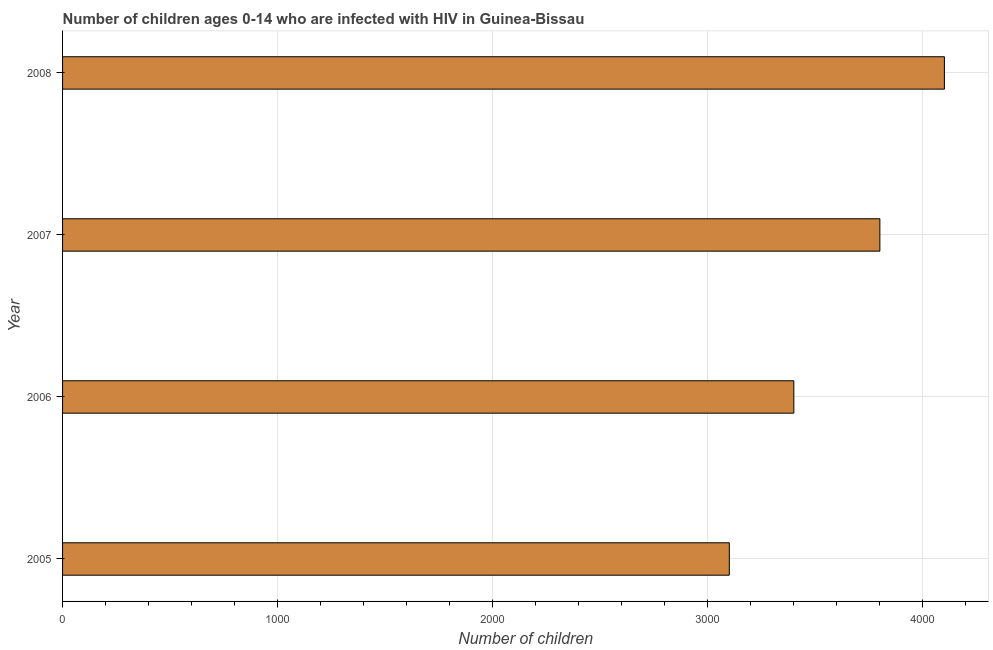Does the graph contain any zero values?
Your answer should be compact. No. Does the graph contain grids?
Give a very brief answer. Yes. What is the title of the graph?
Give a very brief answer. Number of children ages 0-14 who are infected with HIV in Guinea-Bissau. What is the label or title of the X-axis?
Make the answer very short. Number of children. What is the number of children living with hiv in 2008?
Your answer should be compact. 4100. Across all years, what is the maximum number of children living with hiv?
Provide a succinct answer. 4100. Across all years, what is the minimum number of children living with hiv?
Keep it short and to the point. 3100. In which year was the number of children living with hiv maximum?
Your response must be concise. 2008. In which year was the number of children living with hiv minimum?
Your answer should be very brief. 2005. What is the sum of the number of children living with hiv?
Ensure brevity in your answer.  1.44e+04. What is the difference between the number of children living with hiv in 2006 and 2008?
Keep it short and to the point. -700. What is the average number of children living with hiv per year?
Keep it short and to the point. 3600. What is the median number of children living with hiv?
Your answer should be compact. 3600. Do a majority of the years between 2008 and 2007 (inclusive) have number of children living with hiv greater than 200 ?
Offer a terse response. No. What is the ratio of the number of children living with hiv in 2005 to that in 2007?
Provide a short and direct response. 0.82. Is the difference between the number of children living with hiv in 2007 and 2008 greater than the difference between any two years?
Make the answer very short. No. What is the difference between the highest and the second highest number of children living with hiv?
Provide a short and direct response. 300. Is the sum of the number of children living with hiv in 2007 and 2008 greater than the maximum number of children living with hiv across all years?
Your answer should be very brief. Yes. What is the difference between the highest and the lowest number of children living with hiv?
Give a very brief answer. 1000. How many bars are there?
Your answer should be very brief. 4. What is the difference between two consecutive major ticks on the X-axis?
Provide a succinct answer. 1000. Are the values on the major ticks of X-axis written in scientific E-notation?
Your answer should be very brief. No. What is the Number of children in 2005?
Your answer should be very brief. 3100. What is the Number of children in 2006?
Ensure brevity in your answer.  3400. What is the Number of children of 2007?
Provide a short and direct response. 3800. What is the Number of children of 2008?
Ensure brevity in your answer.  4100. What is the difference between the Number of children in 2005 and 2006?
Your response must be concise. -300. What is the difference between the Number of children in 2005 and 2007?
Offer a very short reply. -700. What is the difference between the Number of children in 2005 and 2008?
Ensure brevity in your answer.  -1000. What is the difference between the Number of children in 2006 and 2007?
Ensure brevity in your answer.  -400. What is the difference between the Number of children in 2006 and 2008?
Offer a terse response. -700. What is the difference between the Number of children in 2007 and 2008?
Ensure brevity in your answer.  -300. What is the ratio of the Number of children in 2005 to that in 2006?
Ensure brevity in your answer.  0.91. What is the ratio of the Number of children in 2005 to that in 2007?
Provide a succinct answer. 0.82. What is the ratio of the Number of children in 2005 to that in 2008?
Ensure brevity in your answer.  0.76. What is the ratio of the Number of children in 2006 to that in 2007?
Provide a short and direct response. 0.9. What is the ratio of the Number of children in 2006 to that in 2008?
Keep it short and to the point. 0.83. What is the ratio of the Number of children in 2007 to that in 2008?
Your response must be concise. 0.93. 